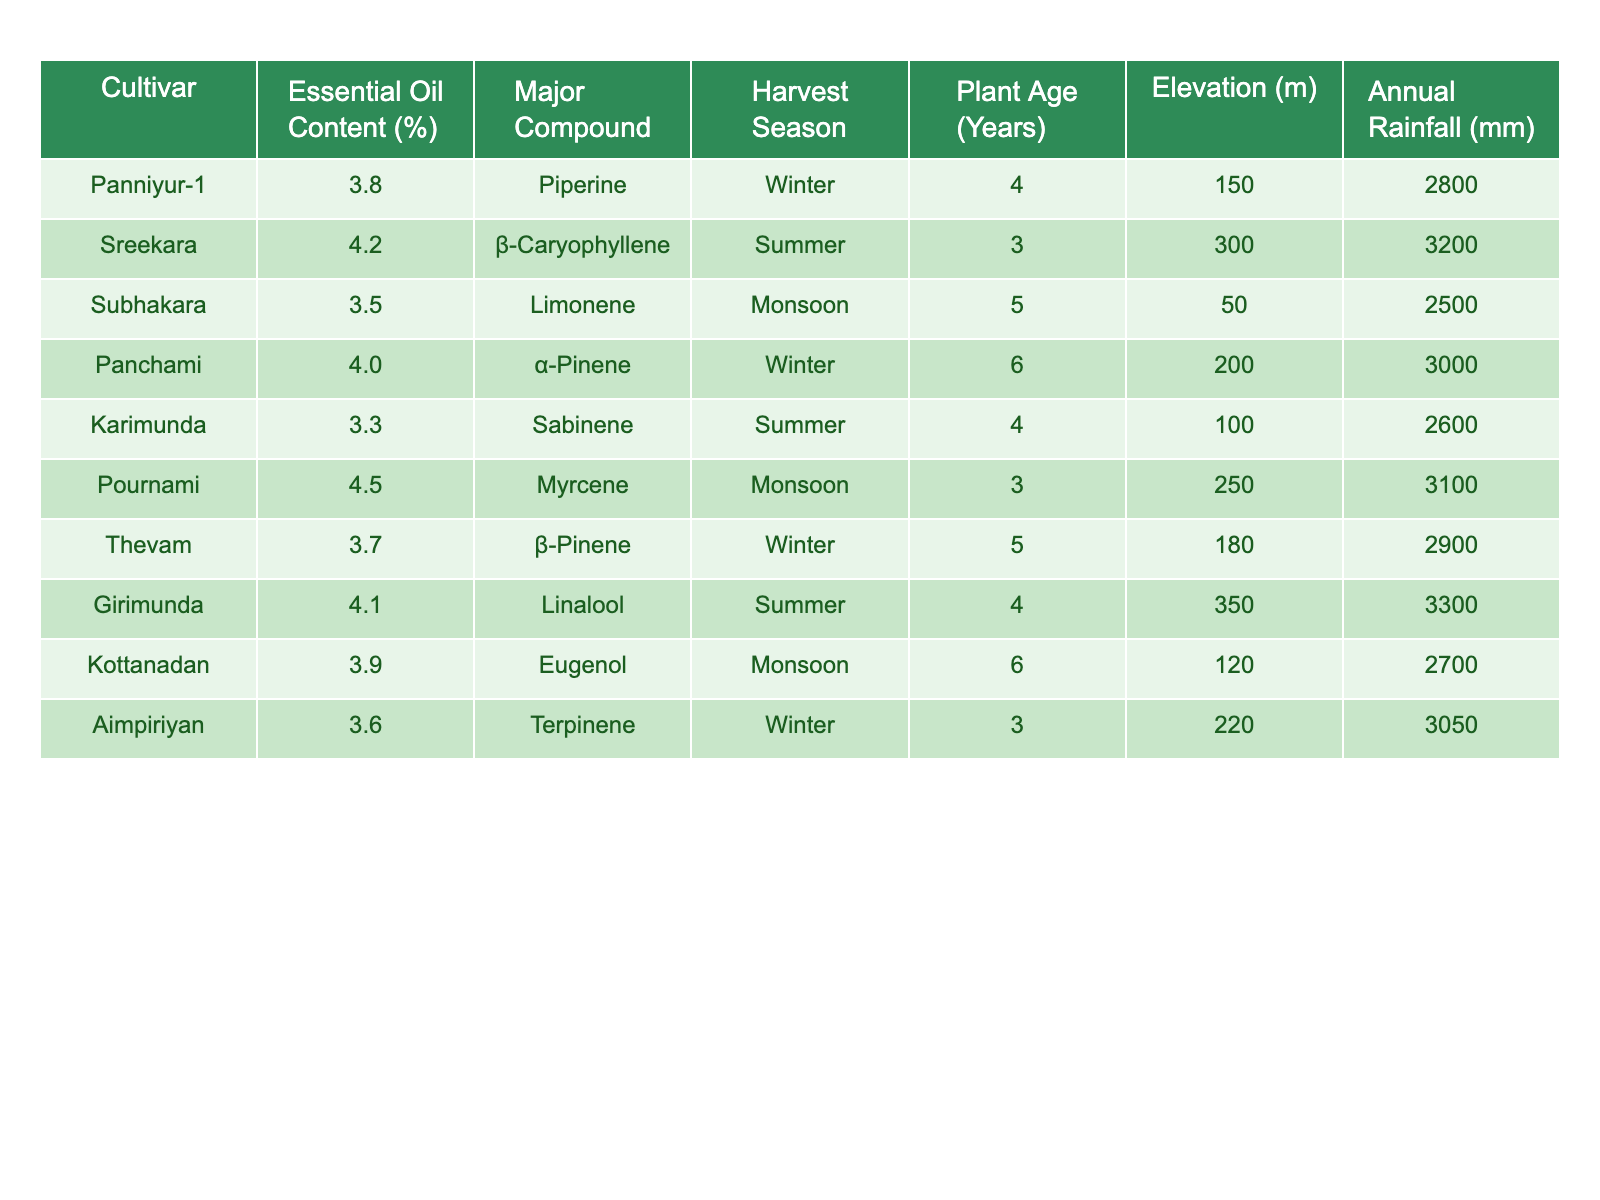What is the essential oil content of the cultivar Pournami? The table shows the essential oil content for each cultivar, and for Pournami, it is listed as 4.5%.
Answer: 4.5% Which cultivar has the highest essential oil content? By comparing the essential oil content percentages in the table, Pournami has the highest content at 4.5%.
Answer: Pournami What is the major compound in the cultivar Girimunda? The table specifies that the major compound in Girimunda is Linalool.
Answer: Linalool What is the average essential oil content among all cultivars? To find the average, add all the essential oil contents: (3.8 + 4.2 + 3.5 + 4.0 + 3.3 + 4.5 + 3.7 + 4.1 + 3.9 + 3.6) = 39.6%. Then divide by 10 cultivars: 39.6 / 10 = 3.96%.
Answer: 3.96% Which cultivar's major compound is Piperine? Referring to the table, Panniyur-1 is identified as having Piperine as its major compound.
Answer: Panniyur-1 Is there any cultivar with an essential oil content below 3.5%? Observing the table, the lowest essential oil content recorded is 3.3% for Karimunda, which confirms that there is a cultivar below 3.5%.
Answer: Yes What is the difference in essential oil content between the highest and lowest cultivars? The highest essential oil content is 4.5% (Pournami) and the lowest is 3.3% (Karimunda). The difference is 4.5 - 3.3 = 1.2%.
Answer: 1.2% How many cultivars are harvested in the winter season? The table indicates the harvest season for each cultivar. The cultivars harvested in winter are Panniyur-1, Panchami, and Thevam, which totals to three cultivars.
Answer: 3 Do the cultivars with the highest essential oil content have the most rain? Pournami (4.5%) has 3100 mm of rainfall and Girimunda (4.1%) has 3300 mm. The cultivar with the lowest essential oil content, Karimunda (3.3%), has 2600 mm. Thus, the highest oil contents do not correspond to the most rain.
Answer: No Which cultivar has the oldest plant age? The table shows that Panchami has a plant age of 6 years, making it the oldest among the cultivars listed.
Answer: Panchami 